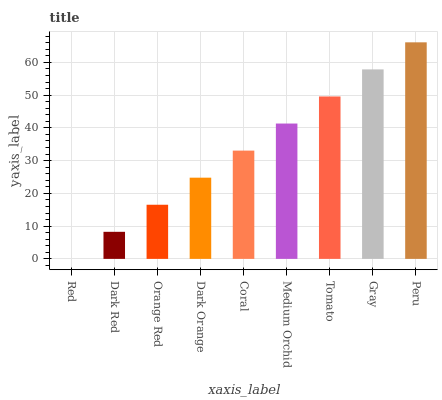Is Red the minimum?
Answer yes or no. Yes. Is Peru the maximum?
Answer yes or no. Yes. Is Dark Red the minimum?
Answer yes or no. No. Is Dark Red the maximum?
Answer yes or no. No. Is Dark Red greater than Red?
Answer yes or no. Yes. Is Red less than Dark Red?
Answer yes or no. Yes. Is Red greater than Dark Red?
Answer yes or no. No. Is Dark Red less than Red?
Answer yes or no. No. Is Coral the high median?
Answer yes or no. Yes. Is Coral the low median?
Answer yes or no. Yes. Is Medium Orchid the high median?
Answer yes or no. No. Is Peru the low median?
Answer yes or no. No. 